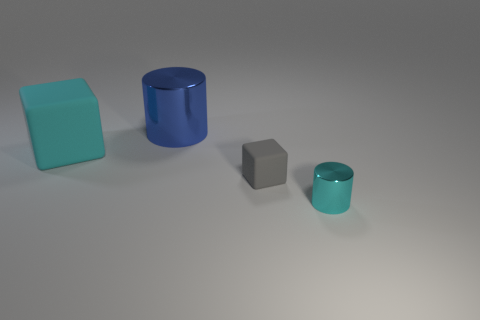There is a block that is right of the large object that is behind the large block; how big is it?
Keep it short and to the point. Small. There is a cyan cylinder that is the same size as the gray rubber cube; what is it made of?
Your answer should be compact. Metal. Are there any tiny gray blocks right of the blue metallic cylinder?
Your answer should be compact. Yes. Are there an equal number of cyan cylinders that are on the left side of the tiny gray cube and big blue balls?
Give a very brief answer. Yes. What shape is the other thing that is the same size as the gray object?
Make the answer very short. Cylinder. What material is the cyan cylinder?
Make the answer very short. Metal. There is a object that is both right of the large shiny thing and behind the tiny cyan thing; what is its color?
Keep it short and to the point. Gray. Are there an equal number of cylinders that are in front of the blue cylinder and small cyan metal things that are left of the small rubber block?
Offer a terse response. No. There is a tiny object that is the same material as the large blue cylinder; what is its color?
Ensure brevity in your answer.  Cyan. Does the tiny metallic thing have the same color as the metal thing left of the tiny cyan object?
Give a very brief answer. No. 